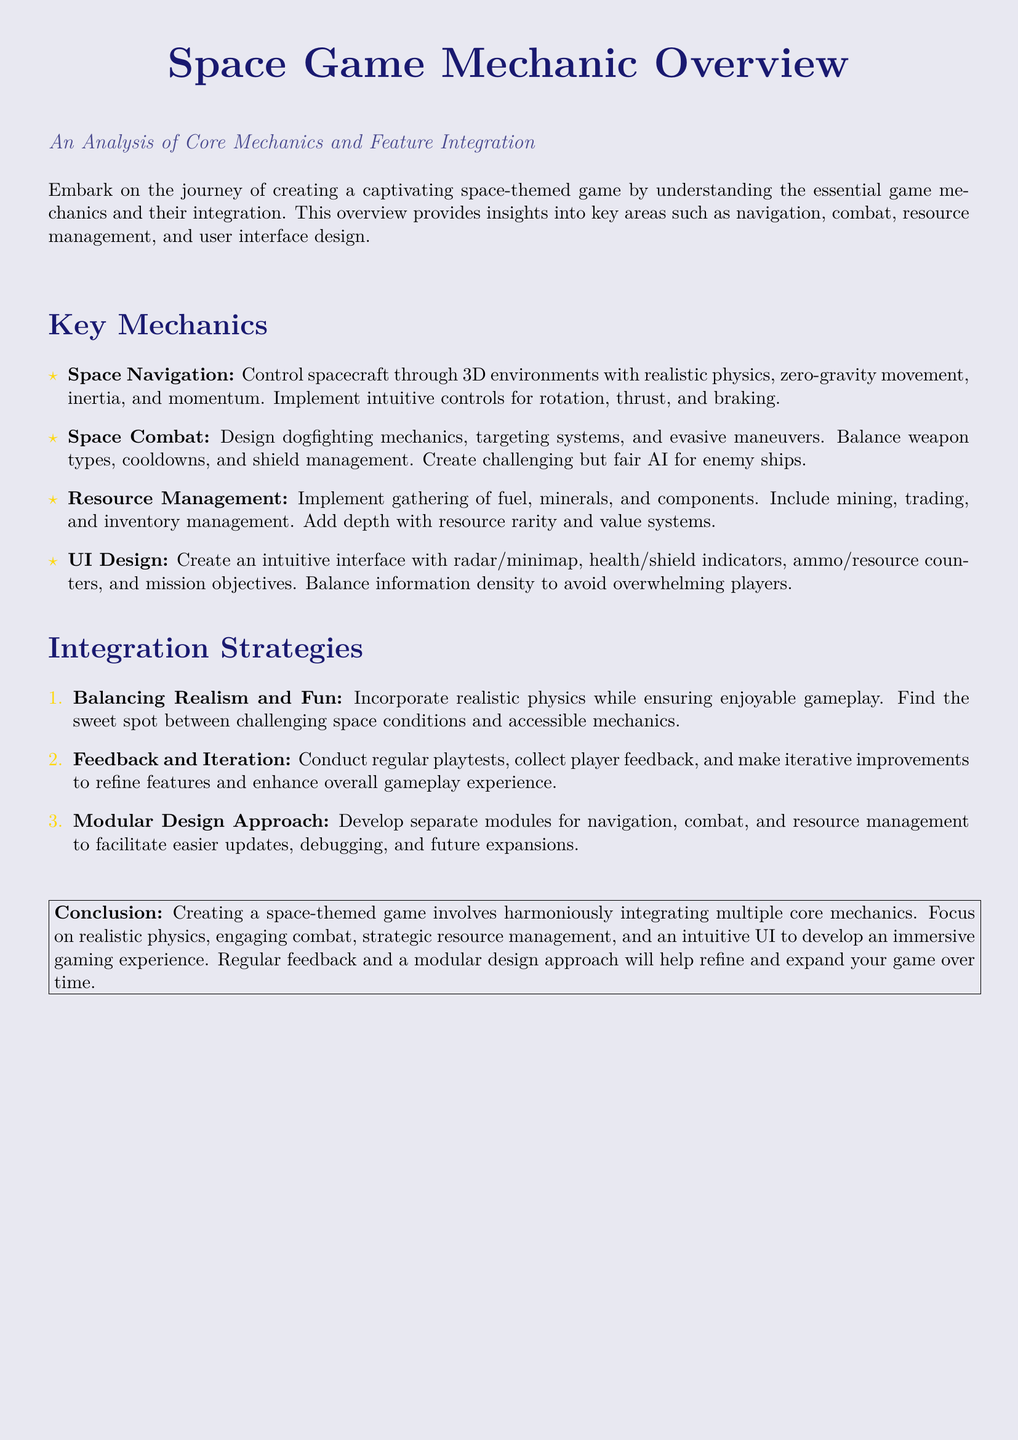What is the title of the document? The title of the document is presented prominently and indicates the main topic of the analysis.
Answer: Space Game Mechanic Overview What is the focus of the analysis? The focus of the analysis is stated right below the title, describing what the overview will cover.
Answer: Core Mechanics and Feature Integration What is one key mechanic discussed? One of the key mechanics is listed in the section labeled "Key Mechanics," exemplifying a crucial aspect of the game.
Answer: Space Navigation What is the first integration strategy mentioned? The first integration strategy listed focuses on a balance between realism and gameplay enjoyment.
Answer: Balancing Realism and Fun What type of design approach is recommended? The document suggests a specific design approach in the "Integration Strategies" section that would benefit the game's development.
Answer: Modular Design Approach What are players supposed to manage in the game? The document points out specific elements that players would collect and use within the game's environment.
Answer: Resources What should UI design avoid? The document emphasizes a key principle in UI design that must be considered to enhance user experience.
Answer: Overwhelming players How many key mechanics are listed? The number of key mechanics is indicated by the number of items in the "Key Mechanics" section.
Answer: Four 